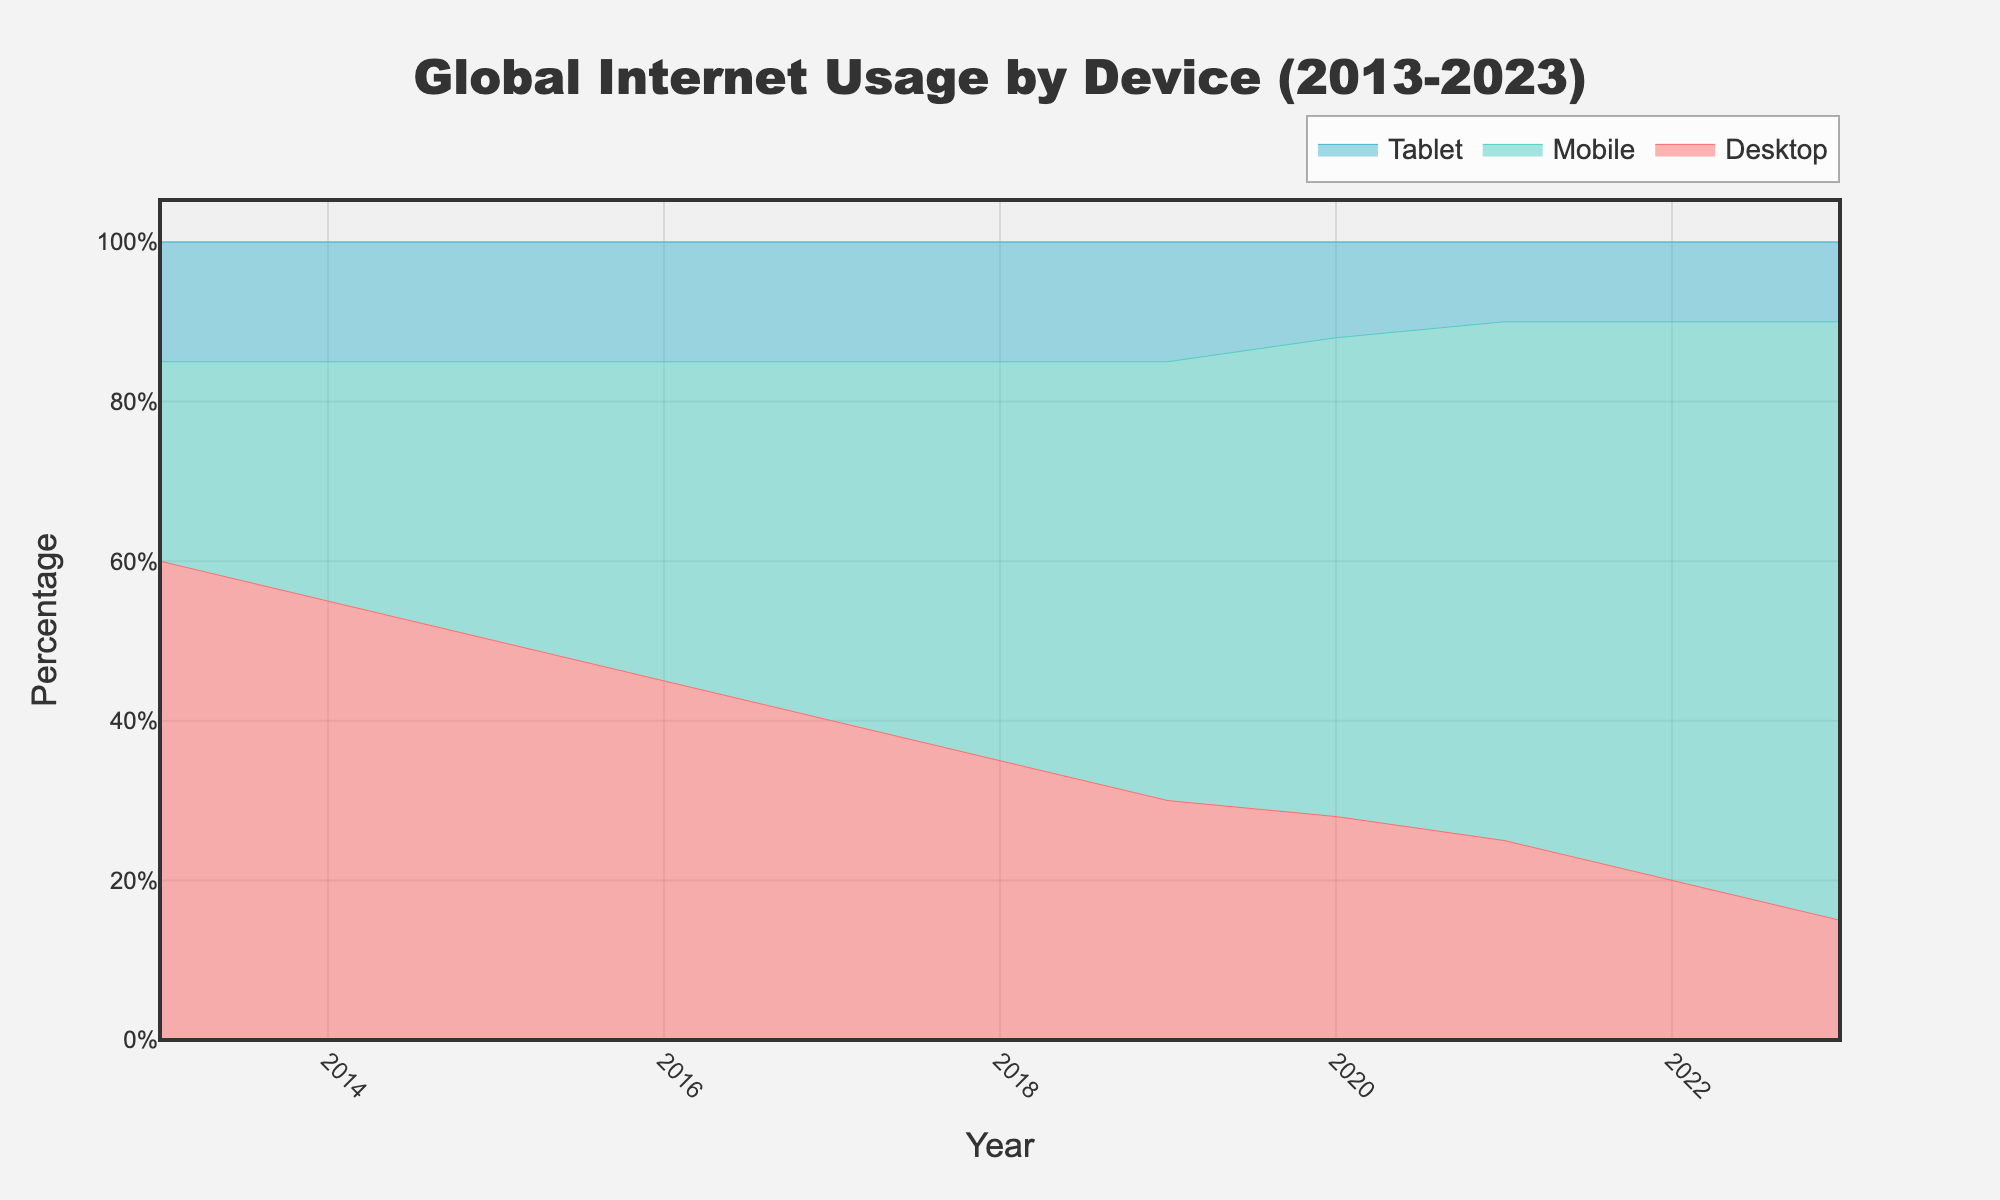What is the title of the area chart? The title is located at the top center of the chart and reads "Global Internet Usage by Device (2013-2023)"
Answer: Global Internet Usage by Device (2013-2023) What colors are used to represent each device type in the chart? The chart uses distinct colors for each device type: Desktop is represented in red, Mobile in turquoise, and Tablet in blue.
Answer: Desktop: red, Mobile: turquoise, Tablet: blue What is the percentage of Mobile usage in the year 2016? In 2016, the chart shows the percentage of Mobile usage at 40%, which can be seen from the y-axis intersection with the "Mobile" area.
Answer: 40% How has Desktop usage changed from 2013 to 2023? To determine this, observe the "Desktop" area in the chart over the given years. In 2013, Desktop usage starts at 60% and decreases steadily to 15% by 2023.
Answer: Reduced from 60% to 15% Which year did Mobile usage surpass Desktop usage? Comparing the graph areas, Mobile usage surpasses Desktop usage in 2016, where the Mobile area (40%) exceeded the Desktop area (45%).
Answer: 2016 What is the sum of the percentages of Desktop and Tablet usage in 2023? In 2023, Desktop usage is 15%, and Tablet usage is 10%. Adding these together gives 15% + 10% = 25%.
Answer: 25% Which device type shows the least change in its percentage usage over the decade? Observing the areas, Tablet usage remains the most stable, consistently around 15%-10% across the years, showing the least variation compared to Desktop and Mobile.
Answer: Tablet What is the percentage difference between Desktop and Mobile usage in 2019? In 2019, Desktop usage is 30%, and Mobile usage is 55%. The difference is calculated as 55% - 30% = 25%.
Answer: 25% How did the percentage of Tablet usage change in the transition from 2020 to 2021? From the chart, Tablet usage decreased from 12% in 2020 to 10% in 2021, which is a change of 12% - 10% = 2%.
Answer: Decreased by 2% What trend can be observed for Mobile usage throughout the decade? Mobile usage shows a consistent upward trend, starting from 25% in 2013 and rising to 75% by 2023.
Answer: Increasing trend 